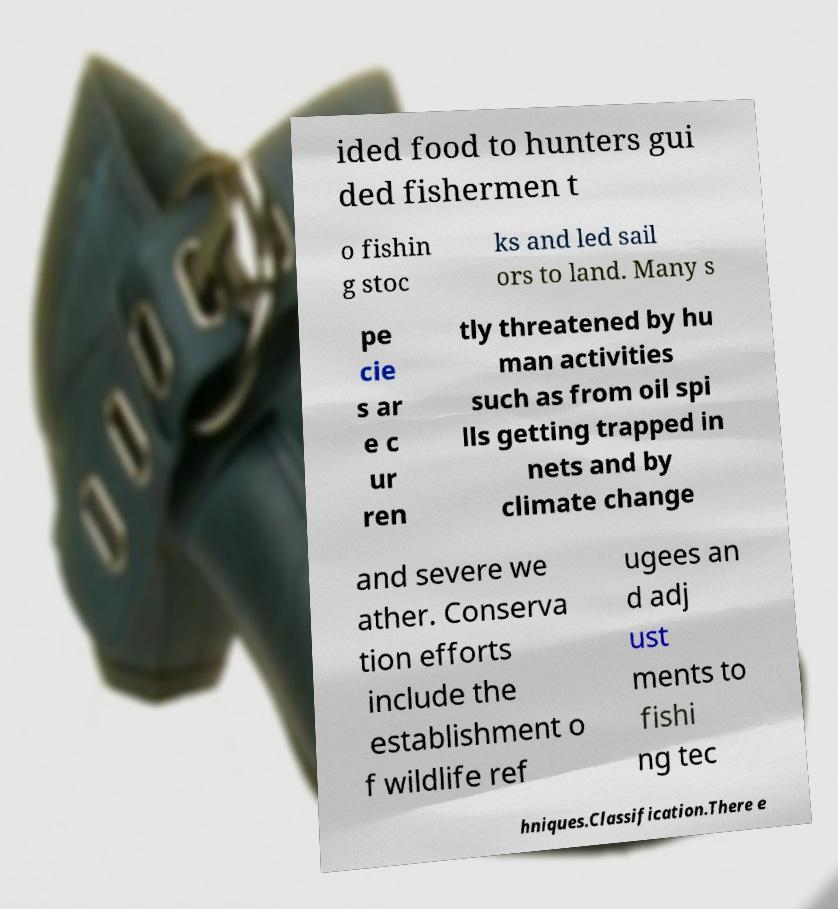Could you extract and type out the text from this image? ided food to hunters gui ded fishermen t o fishin g stoc ks and led sail ors to land. Many s pe cie s ar e c ur ren tly threatened by hu man activities such as from oil spi lls getting trapped in nets and by climate change and severe we ather. Conserva tion efforts include the establishment o f wildlife ref ugees an d adj ust ments to fishi ng tec hniques.Classification.There e 